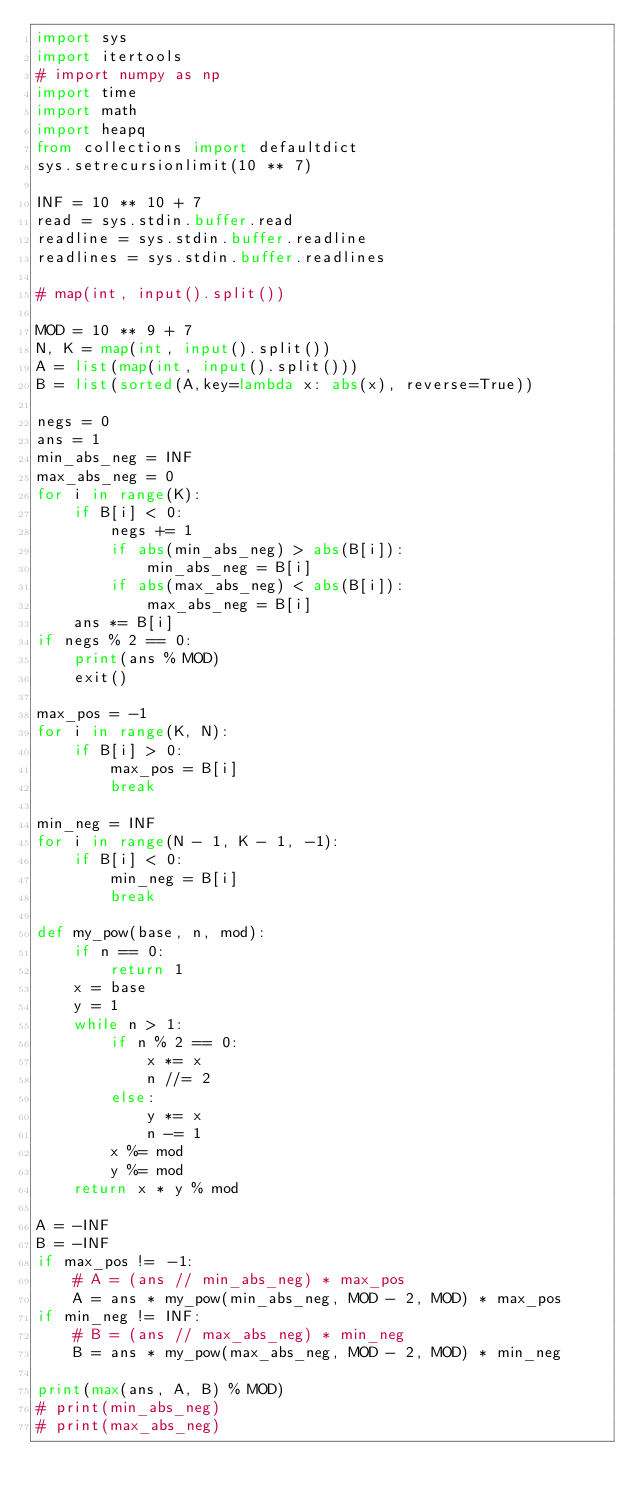Convert code to text. <code><loc_0><loc_0><loc_500><loc_500><_Python_>import sys
import itertools
# import numpy as np
import time
import math
import heapq
from collections import defaultdict
sys.setrecursionlimit(10 ** 7)
 
INF = 10 ** 10 + 7
read = sys.stdin.buffer.read
readline = sys.stdin.buffer.readline
readlines = sys.stdin.buffer.readlines

# map(int, input().split())

MOD = 10 ** 9 + 7
N, K = map(int, input().split())
A = list(map(int, input().split()))
B = list(sorted(A,key=lambda x: abs(x), reverse=True))

negs = 0
ans = 1
min_abs_neg = INF
max_abs_neg = 0
for i in range(K):
    if B[i] < 0:
        negs += 1
        if abs(min_abs_neg) > abs(B[i]):
            min_abs_neg = B[i]
        if abs(max_abs_neg) < abs(B[i]):
            max_abs_neg = B[i]
    ans *= B[i]
if negs % 2 == 0:
    print(ans % MOD)
    exit()

max_pos = -1
for i in range(K, N):
    if B[i] > 0:
        max_pos = B[i]
        break

min_neg = INF
for i in range(N - 1, K - 1, -1):
    if B[i] < 0:
        min_neg = B[i]
        break

def my_pow(base, n, mod):
    if n == 0:
        return 1
    x = base
    y = 1
    while n > 1:
        if n % 2 == 0:
            x *= x
            n //= 2
        else:
            y *= x
            n -= 1
        x %= mod
        y %= mod
    return x * y % mod

A = -INF
B = -INF
if max_pos != -1:
    # A = (ans // min_abs_neg) * max_pos
    A = ans * my_pow(min_abs_neg, MOD - 2, MOD) * max_pos
if min_neg != INF:
    # B = (ans // max_abs_neg) * min_neg
    B = ans * my_pow(max_abs_neg, MOD - 2, MOD) * min_neg

print(max(ans, A, B) % MOD)
# print(min_abs_neg)
# print(max_abs_neg)




</code> 